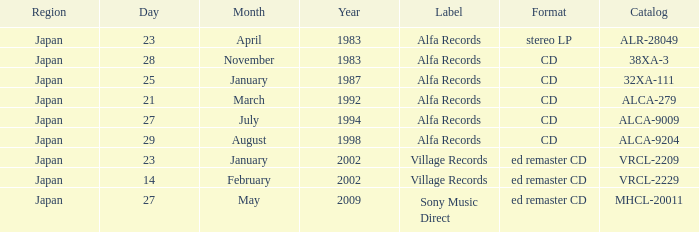Which catalog is in cd format? 38XA-3, 32XA-111, ALCA-279, ALCA-9009, ALCA-9204. 